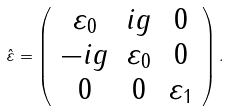<formula> <loc_0><loc_0><loc_500><loc_500>\hat { \varepsilon } = \left ( \begin{array} { c c c } \varepsilon _ { 0 } & i g & 0 \\ - i g & \varepsilon _ { 0 } & 0 \\ 0 & 0 & \varepsilon _ { 1 } \end{array} \right ) .</formula> 